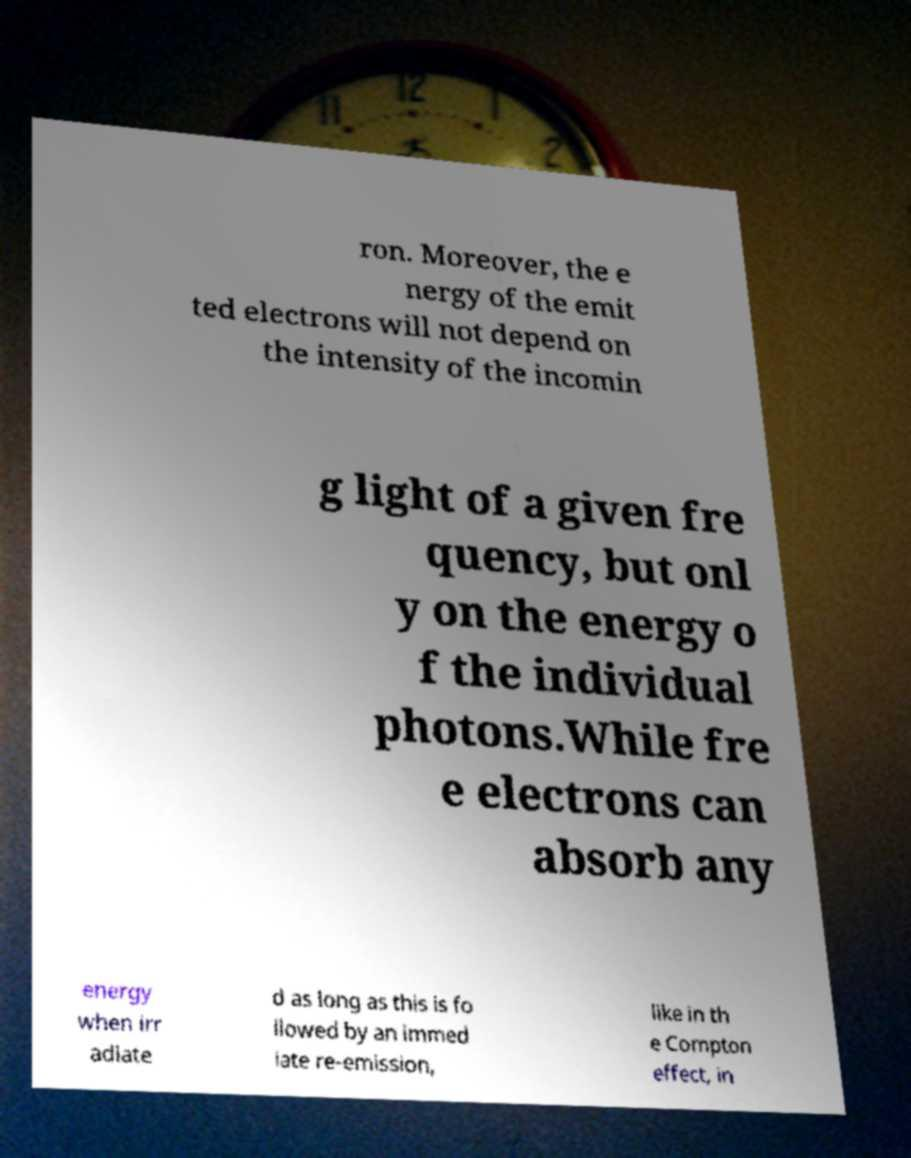Can you read and provide the text displayed in the image?This photo seems to have some interesting text. Can you extract and type it out for me? ron. Moreover, the e nergy of the emit ted electrons will not depend on the intensity of the incomin g light of a given fre quency, but onl y on the energy o f the individual photons.While fre e electrons can absorb any energy when irr adiate d as long as this is fo llowed by an immed iate re-emission, like in th e Compton effect, in 